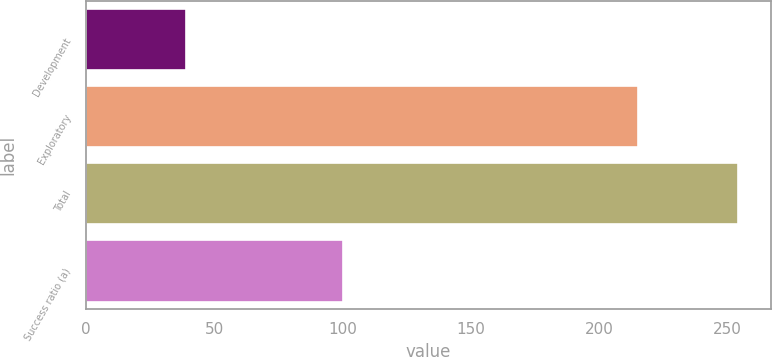Convert chart. <chart><loc_0><loc_0><loc_500><loc_500><bar_chart><fcel>Development<fcel>Exploratory<fcel>Total<fcel>Success ratio (a)<nl><fcel>39<fcel>215<fcel>254<fcel>100<nl></chart> 